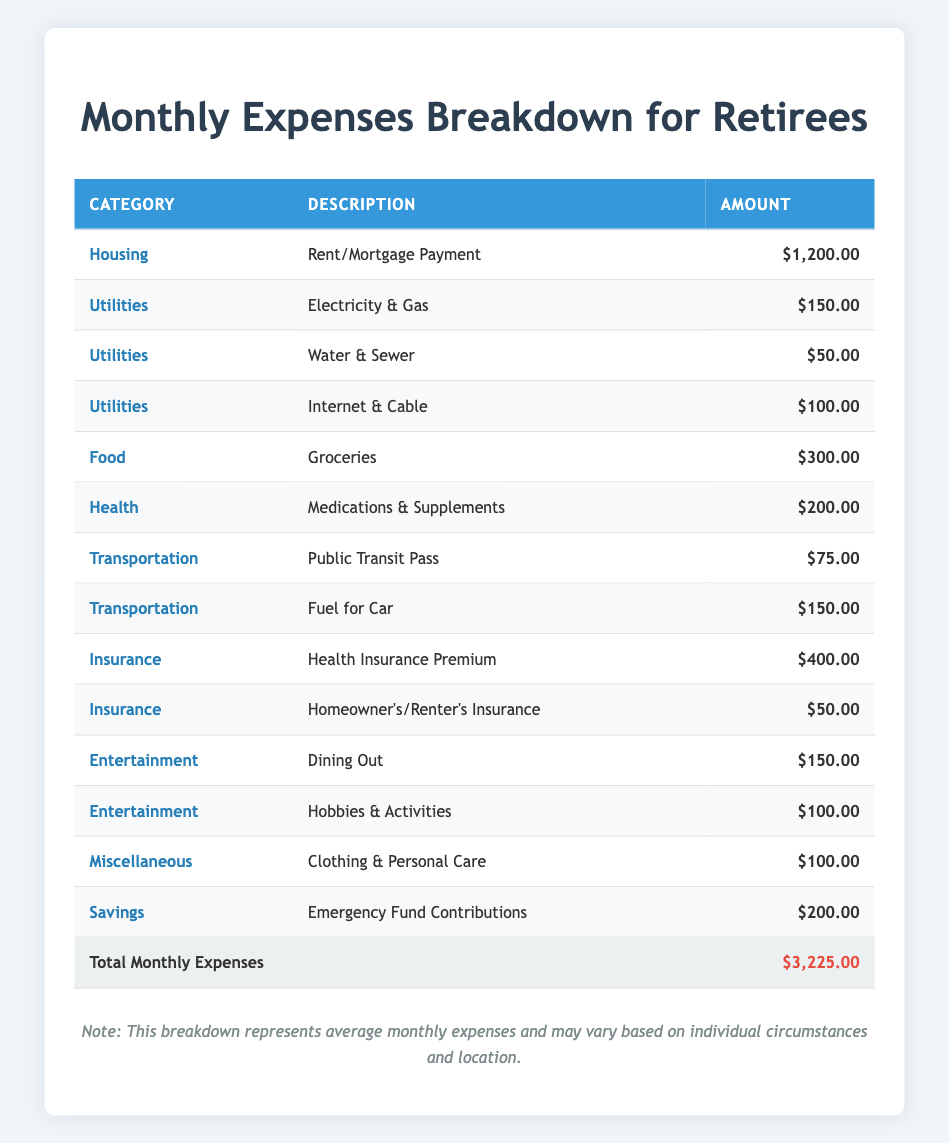What is the total monthly expense for housing? The table indicates the monthly expense for housing is solely from the Rent/Mortgage Payment category, which is $1,200.00. Thus, the total monthly expense for housing is just that amount.
Answer: $1,200.00 Which category has the highest monthly expense? The highest monthly expense is found under the Insurance category, specifically the Health Insurance Premium, which amounts to $400.00.
Answer: $400.00 What is the total amount spent on utilities each month? To find the total for utilities, we sum the amounts in the Utilities category: Electricity & Gas ($150), Water & Sewer ($50), and Internet & Cable ($100). The total is $150 + $50 + $100 = $300.
Answer: $300.00 Is the total for entertainment expenses greater than the total for food expenses? The total for entertainment is $150 (Dining Out) + $100 (Hobbies & Activities) = $250. The total for food is $300 (Groceries). Since $250 is less than $300, the statement is false.
Answer: No If you include emergency fund contributions, what is the new total monthly expense? The original total for monthly expenses is $3,225.00. Including the emergency fund contribution of $200 results in a new total: $3,225 + $200 = $3,425.
Answer: $3,425.00 What percentage of the total monthly expense is spent on health-related costs? The sum of health-related costs is Health Insurance Premium ($400) + Medications & Supplements ($200) = $600. To find the percentage of the total monthly expense, we divide $600 by $3,225 and multiply by 100: (600 / 3,225) * 100 ≈ 18.6%.
Answer: 18.6% How much is spent on transportation compared to housing each month? The transportation expenses are Public Transit Pass ($75) and Fuel for Car ($150), totaling $225. The housing expense is $1,200. We compare the two: $225 is less than $1,200.
Answer: $225 Does the total for miscellaneous expenses exceed $150? The amount for miscellaneous expenses is $100 (Clothing & Personal Care). This is less than $150, so the answer is no.
Answer: No What is the average monthly expense across all categories? First, we sum all monthly expenses: $3,225.00 is the total. There are 14 expense entries. To find the average, we divide total expenses by entries: $3,225.00 / 14 ≈ $230.36.
Answer: $230.36 